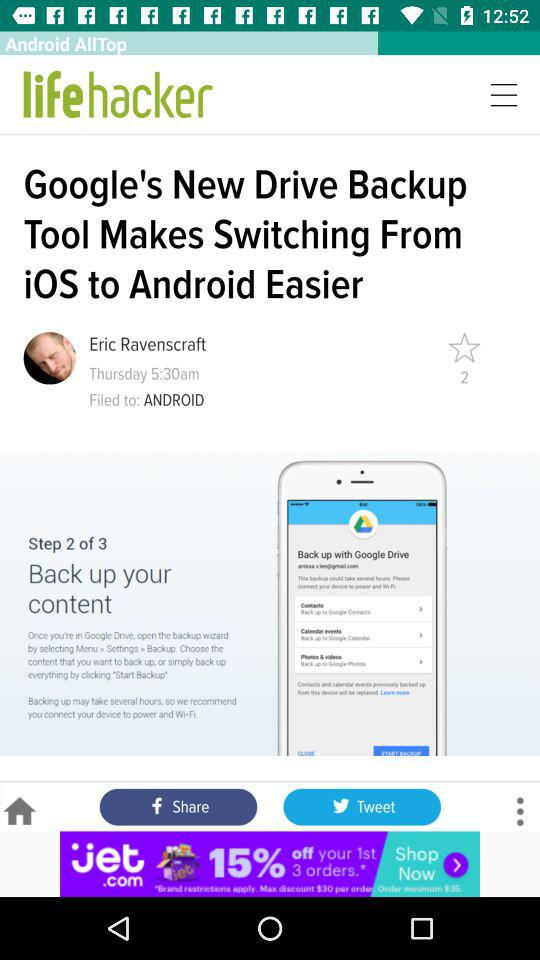What is the name of the user? The name of the user is Eric Ravenscraft. 